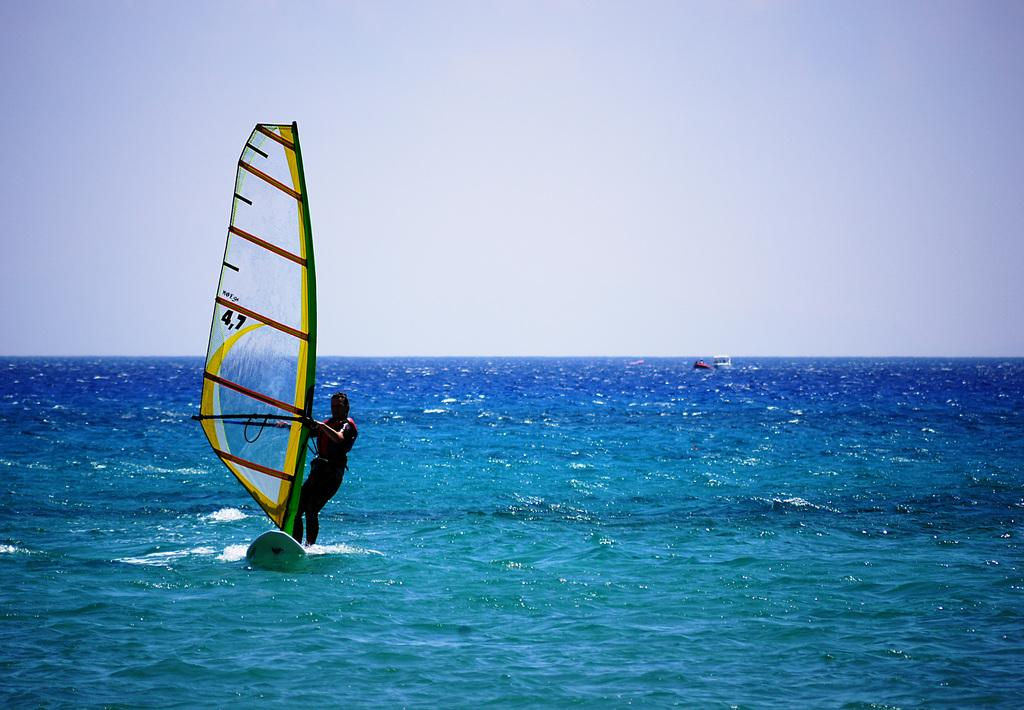Who is the main subject in the image? There is a man in the image. What is the man doing in the image? The man is surfing on water. Where is the man giving birth in the image? There is no indication of a birth or a woman in the image; it features a man surfing on water. 